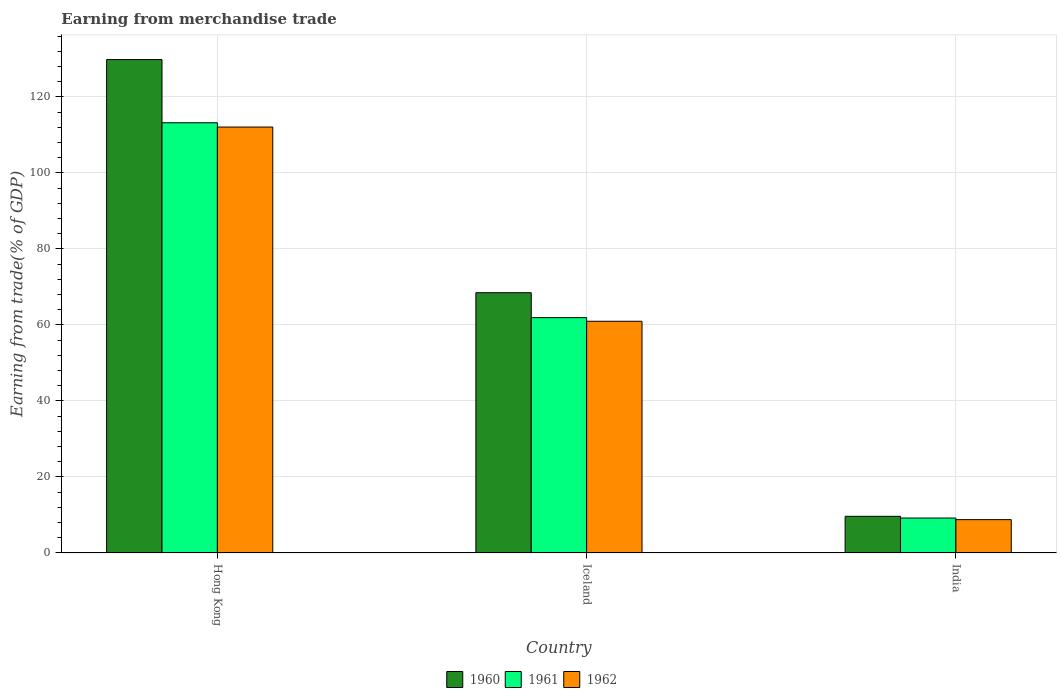How many different coloured bars are there?
Give a very brief answer. 3. How many groups of bars are there?
Make the answer very short. 3. Are the number of bars per tick equal to the number of legend labels?
Your answer should be compact. Yes. Are the number of bars on each tick of the X-axis equal?
Your answer should be very brief. Yes. How many bars are there on the 1st tick from the right?
Provide a succinct answer. 3. What is the label of the 2nd group of bars from the left?
Give a very brief answer. Iceland. What is the earnings from trade in 1960 in Hong Kong?
Your answer should be very brief. 129.85. Across all countries, what is the maximum earnings from trade in 1962?
Your answer should be very brief. 112.08. Across all countries, what is the minimum earnings from trade in 1960?
Make the answer very short. 9.65. In which country was the earnings from trade in 1962 maximum?
Give a very brief answer. Hong Kong. What is the total earnings from trade in 1960 in the graph?
Your answer should be very brief. 207.98. What is the difference between the earnings from trade in 1960 in Hong Kong and that in Iceland?
Provide a succinct answer. 61.35. What is the difference between the earnings from trade in 1962 in Iceland and the earnings from trade in 1960 in India?
Keep it short and to the point. 51.33. What is the average earnings from trade in 1961 per country?
Your answer should be very brief. 61.45. What is the difference between the earnings from trade of/in 1961 and earnings from trade of/in 1960 in Hong Kong?
Your response must be concise. -16.63. In how many countries, is the earnings from trade in 1962 greater than 108 %?
Offer a very short reply. 1. What is the ratio of the earnings from trade in 1961 in Hong Kong to that in Iceland?
Keep it short and to the point. 1.83. Is the earnings from trade in 1961 in Hong Kong less than that in India?
Your answer should be very brief. No. What is the difference between the highest and the second highest earnings from trade in 1962?
Keep it short and to the point. 103.3. What is the difference between the highest and the lowest earnings from trade in 1962?
Ensure brevity in your answer.  103.3. Is the sum of the earnings from trade in 1960 in Hong Kong and Iceland greater than the maximum earnings from trade in 1961 across all countries?
Provide a short and direct response. Yes. What is the difference between two consecutive major ticks on the Y-axis?
Your answer should be compact. 20. Are the values on the major ticks of Y-axis written in scientific E-notation?
Provide a short and direct response. No. Does the graph contain any zero values?
Ensure brevity in your answer.  No. Does the graph contain grids?
Make the answer very short. Yes. What is the title of the graph?
Provide a succinct answer. Earning from merchandise trade. What is the label or title of the X-axis?
Give a very brief answer. Country. What is the label or title of the Y-axis?
Keep it short and to the point. Earning from trade(% of GDP). What is the Earning from trade(% of GDP) of 1960 in Hong Kong?
Your response must be concise. 129.85. What is the Earning from trade(% of GDP) in 1961 in Hong Kong?
Ensure brevity in your answer.  113.21. What is the Earning from trade(% of GDP) in 1962 in Hong Kong?
Keep it short and to the point. 112.08. What is the Earning from trade(% of GDP) of 1960 in Iceland?
Offer a very short reply. 68.49. What is the Earning from trade(% of GDP) of 1961 in Iceland?
Your answer should be very brief. 61.93. What is the Earning from trade(% of GDP) of 1962 in Iceland?
Your answer should be compact. 60.97. What is the Earning from trade(% of GDP) of 1960 in India?
Give a very brief answer. 9.65. What is the Earning from trade(% of GDP) of 1961 in India?
Offer a very short reply. 9.2. What is the Earning from trade(% of GDP) of 1962 in India?
Make the answer very short. 8.78. Across all countries, what is the maximum Earning from trade(% of GDP) of 1960?
Give a very brief answer. 129.85. Across all countries, what is the maximum Earning from trade(% of GDP) in 1961?
Keep it short and to the point. 113.21. Across all countries, what is the maximum Earning from trade(% of GDP) in 1962?
Ensure brevity in your answer.  112.08. Across all countries, what is the minimum Earning from trade(% of GDP) in 1960?
Your response must be concise. 9.65. Across all countries, what is the minimum Earning from trade(% of GDP) of 1961?
Offer a terse response. 9.2. Across all countries, what is the minimum Earning from trade(% of GDP) of 1962?
Your response must be concise. 8.78. What is the total Earning from trade(% of GDP) in 1960 in the graph?
Your answer should be very brief. 207.98. What is the total Earning from trade(% of GDP) of 1961 in the graph?
Make the answer very short. 184.34. What is the total Earning from trade(% of GDP) of 1962 in the graph?
Provide a short and direct response. 181.83. What is the difference between the Earning from trade(% of GDP) in 1960 in Hong Kong and that in Iceland?
Your answer should be compact. 61.35. What is the difference between the Earning from trade(% of GDP) of 1961 in Hong Kong and that in Iceland?
Your response must be concise. 51.28. What is the difference between the Earning from trade(% of GDP) of 1962 in Hong Kong and that in Iceland?
Offer a very short reply. 51.11. What is the difference between the Earning from trade(% of GDP) in 1960 in Hong Kong and that in India?
Keep it short and to the point. 120.2. What is the difference between the Earning from trade(% of GDP) in 1961 in Hong Kong and that in India?
Provide a succinct answer. 104.02. What is the difference between the Earning from trade(% of GDP) of 1962 in Hong Kong and that in India?
Ensure brevity in your answer.  103.3. What is the difference between the Earning from trade(% of GDP) of 1960 in Iceland and that in India?
Provide a succinct answer. 58.84. What is the difference between the Earning from trade(% of GDP) in 1961 in Iceland and that in India?
Ensure brevity in your answer.  52.73. What is the difference between the Earning from trade(% of GDP) in 1962 in Iceland and that in India?
Your answer should be compact. 52.2. What is the difference between the Earning from trade(% of GDP) of 1960 in Hong Kong and the Earning from trade(% of GDP) of 1961 in Iceland?
Give a very brief answer. 67.91. What is the difference between the Earning from trade(% of GDP) in 1960 in Hong Kong and the Earning from trade(% of GDP) in 1962 in Iceland?
Make the answer very short. 68.87. What is the difference between the Earning from trade(% of GDP) of 1961 in Hong Kong and the Earning from trade(% of GDP) of 1962 in Iceland?
Your response must be concise. 52.24. What is the difference between the Earning from trade(% of GDP) in 1960 in Hong Kong and the Earning from trade(% of GDP) in 1961 in India?
Your answer should be very brief. 120.65. What is the difference between the Earning from trade(% of GDP) of 1960 in Hong Kong and the Earning from trade(% of GDP) of 1962 in India?
Make the answer very short. 121.07. What is the difference between the Earning from trade(% of GDP) in 1961 in Hong Kong and the Earning from trade(% of GDP) in 1962 in India?
Provide a succinct answer. 104.44. What is the difference between the Earning from trade(% of GDP) of 1960 in Iceland and the Earning from trade(% of GDP) of 1961 in India?
Give a very brief answer. 59.29. What is the difference between the Earning from trade(% of GDP) in 1960 in Iceland and the Earning from trade(% of GDP) in 1962 in India?
Your answer should be very brief. 59.71. What is the difference between the Earning from trade(% of GDP) in 1961 in Iceland and the Earning from trade(% of GDP) in 1962 in India?
Offer a very short reply. 53.16. What is the average Earning from trade(% of GDP) in 1960 per country?
Provide a succinct answer. 69.33. What is the average Earning from trade(% of GDP) of 1961 per country?
Provide a short and direct response. 61.45. What is the average Earning from trade(% of GDP) of 1962 per country?
Offer a terse response. 60.61. What is the difference between the Earning from trade(% of GDP) in 1960 and Earning from trade(% of GDP) in 1961 in Hong Kong?
Your answer should be compact. 16.63. What is the difference between the Earning from trade(% of GDP) of 1960 and Earning from trade(% of GDP) of 1962 in Hong Kong?
Your response must be concise. 17.76. What is the difference between the Earning from trade(% of GDP) in 1961 and Earning from trade(% of GDP) in 1962 in Hong Kong?
Ensure brevity in your answer.  1.13. What is the difference between the Earning from trade(% of GDP) in 1960 and Earning from trade(% of GDP) in 1961 in Iceland?
Your answer should be very brief. 6.56. What is the difference between the Earning from trade(% of GDP) in 1960 and Earning from trade(% of GDP) in 1962 in Iceland?
Ensure brevity in your answer.  7.52. What is the difference between the Earning from trade(% of GDP) of 1961 and Earning from trade(% of GDP) of 1962 in Iceland?
Provide a short and direct response. 0.96. What is the difference between the Earning from trade(% of GDP) of 1960 and Earning from trade(% of GDP) of 1961 in India?
Make the answer very short. 0.45. What is the difference between the Earning from trade(% of GDP) in 1960 and Earning from trade(% of GDP) in 1962 in India?
Offer a very short reply. 0.87. What is the difference between the Earning from trade(% of GDP) in 1961 and Earning from trade(% of GDP) in 1962 in India?
Give a very brief answer. 0.42. What is the ratio of the Earning from trade(% of GDP) in 1960 in Hong Kong to that in Iceland?
Offer a terse response. 1.9. What is the ratio of the Earning from trade(% of GDP) of 1961 in Hong Kong to that in Iceland?
Offer a terse response. 1.83. What is the ratio of the Earning from trade(% of GDP) of 1962 in Hong Kong to that in Iceland?
Give a very brief answer. 1.84. What is the ratio of the Earning from trade(% of GDP) in 1960 in Hong Kong to that in India?
Keep it short and to the point. 13.46. What is the ratio of the Earning from trade(% of GDP) of 1961 in Hong Kong to that in India?
Ensure brevity in your answer.  12.31. What is the ratio of the Earning from trade(% of GDP) in 1962 in Hong Kong to that in India?
Your response must be concise. 12.77. What is the ratio of the Earning from trade(% of GDP) in 1960 in Iceland to that in India?
Ensure brevity in your answer.  7.1. What is the ratio of the Earning from trade(% of GDP) of 1961 in Iceland to that in India?
Offer a terse response. 6.73. What is the ratio of the Earning from trade(% of GDP) of 1962 in Iceland to that in India?
Keep it short and to the point. 6.95. What is the difference between the highest and the second highest Earning from trade(% of GDP) in 1960?
Offer a terse response. 61.35. What is the difference between the highest and the second highest Earning from trade(% of GDP) in 1961?
Your answer should be compact. 51.28. What is the difference between the highest and the second highest Earning from trade(% of GDP) in 1962?
Your answer should be very brief. 51.11. What is the difference between the highest and the lowest Earning from trade(% of GDP) in 1960?
Keep it short and to the point. 120.2. What is the difference between the highest and the lowest Earning from trade(% of GDP) in 1961?
Keep it short and to the point. 104.02. What is the difference between the highest and the lowest Earning from trade(% of GDP) in 1962?
Make the answer very short. 103.3. 